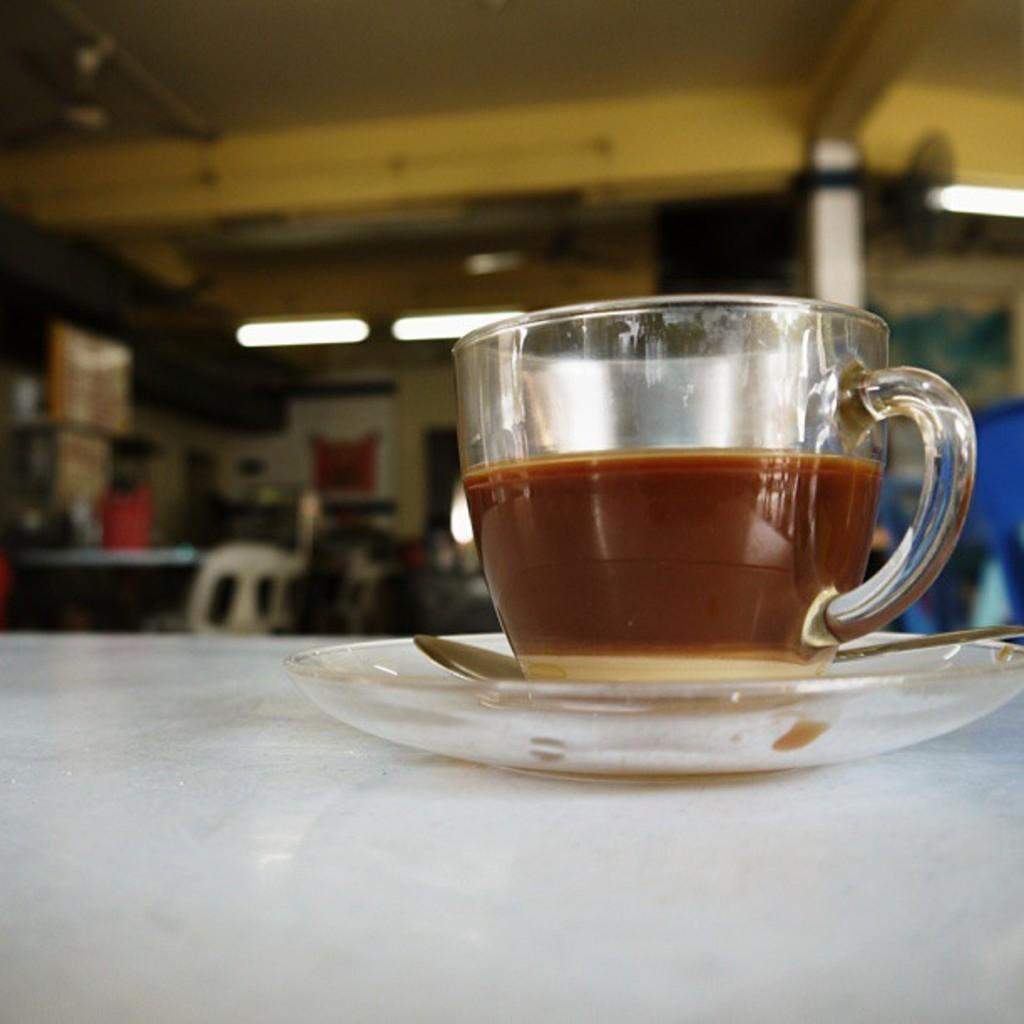What is the main object on the table in the image? There is a cup in the image. What other objects are on the table with the cup? There is a saucer and a spoon in the image. Where are these objects located? All these objects are on a table. Can you describe the background of the image? The background of the image is blurry. What is the opinion of the cup on the table in the image? The cup does not have an opinion, as it is an inanimate object. 